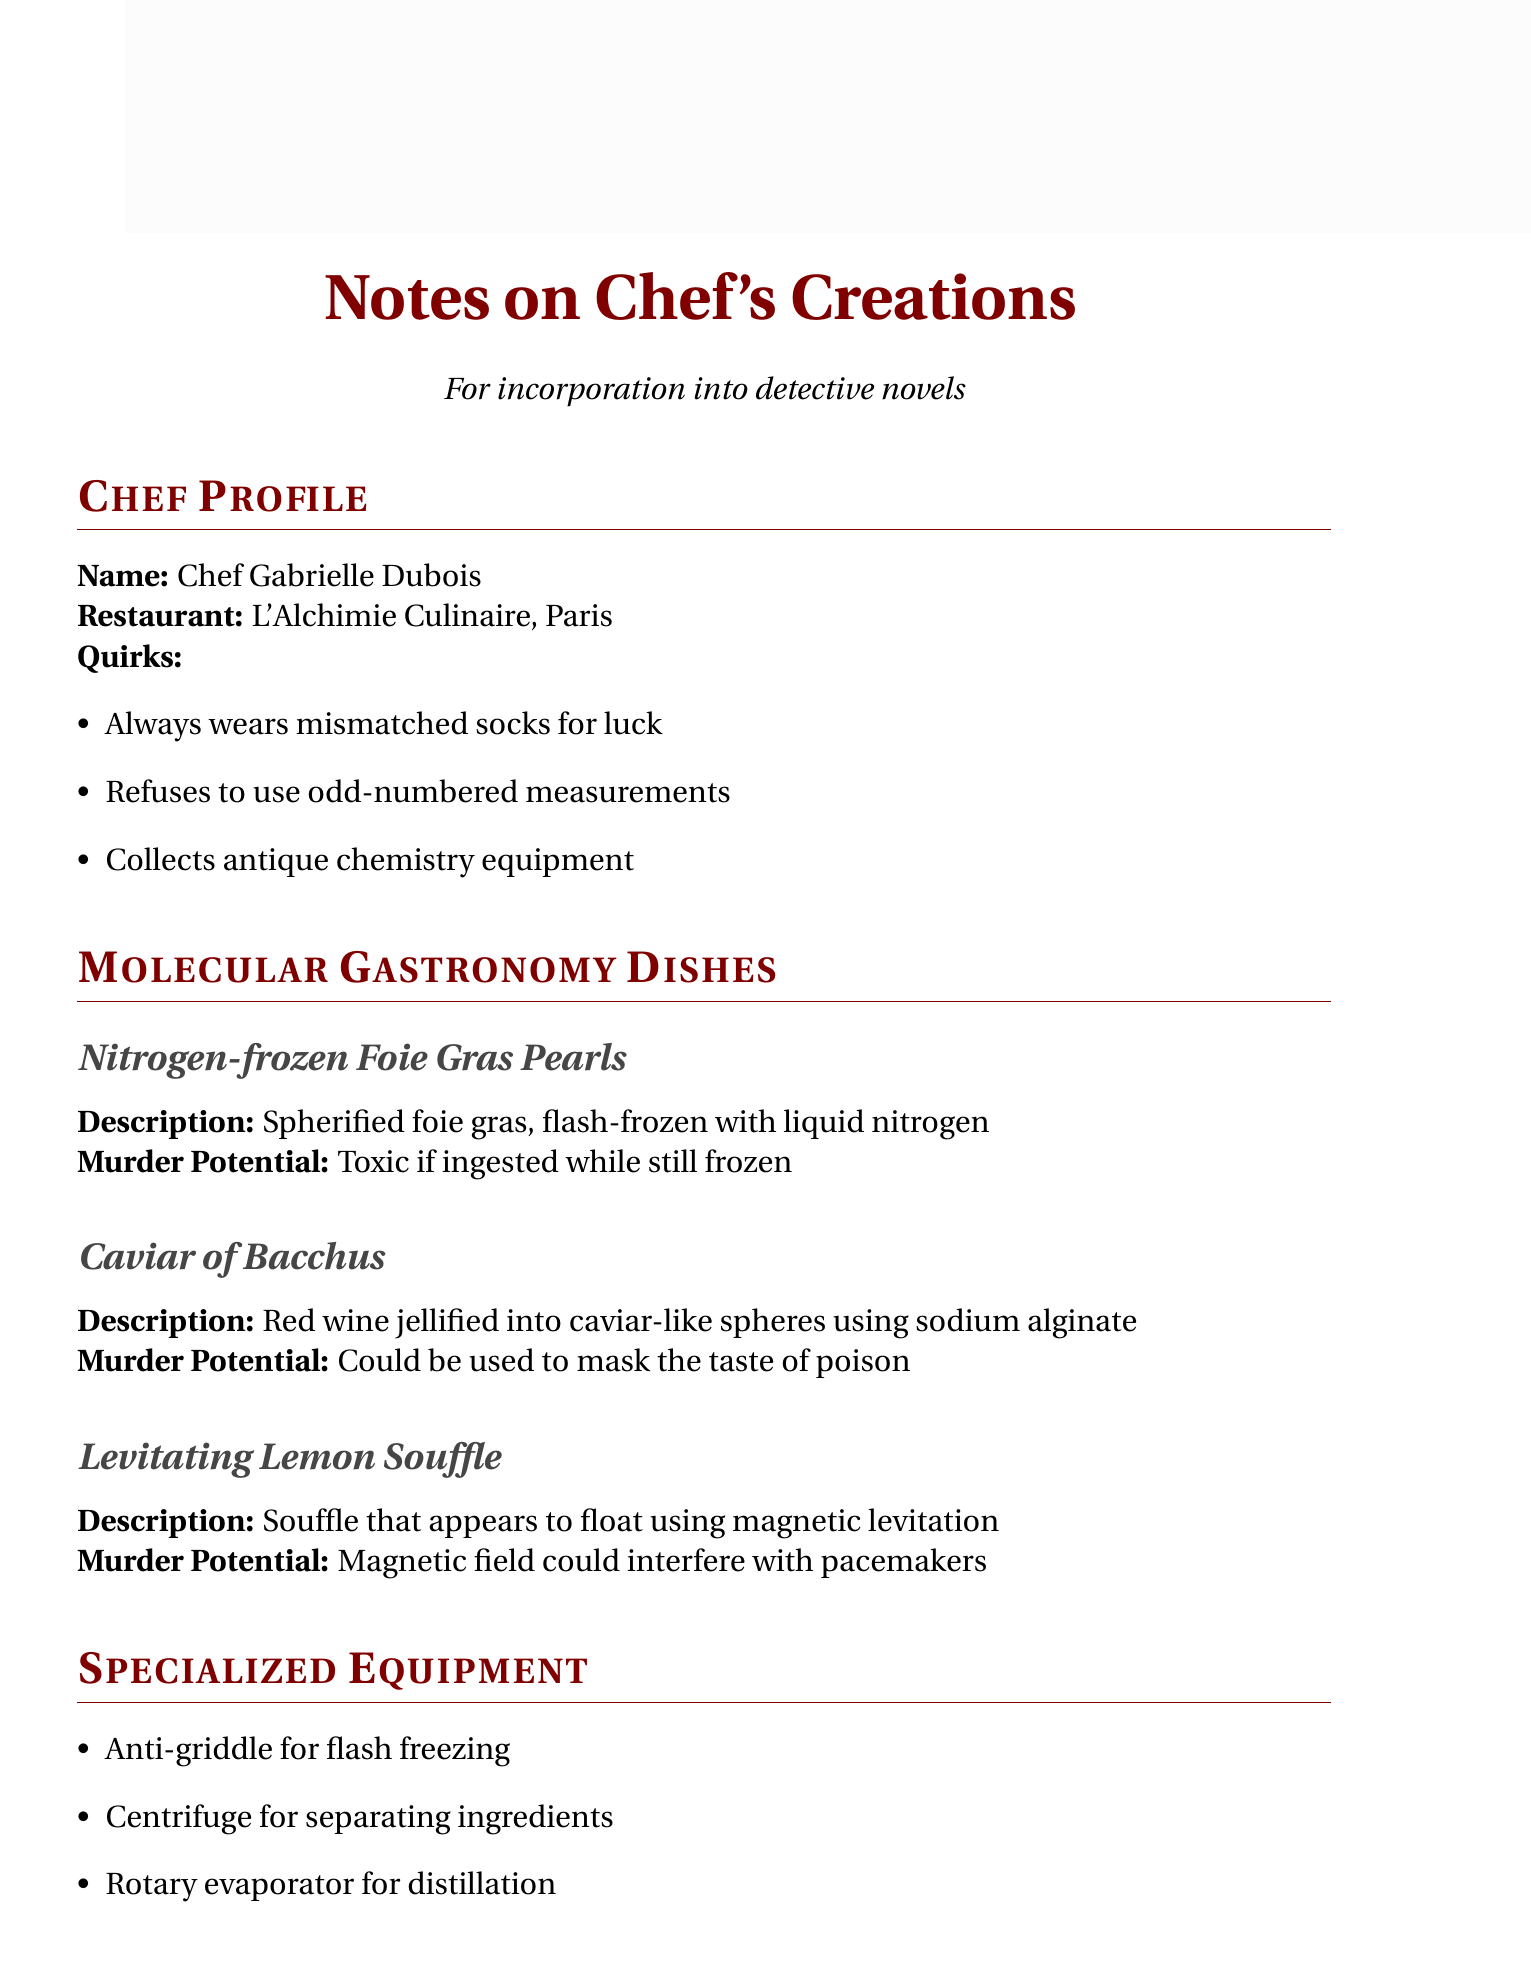What is the chef's name? The chef's name is listed at the top of the document under the Chef Profile section.
Answer: Chef Gabrielle Dubois What is the name of the restaurant? The restaurant name is mentioned in the Chef Profile section.
Answer: L'Alchimie Culinaire, Paris What is a key ingredient used in the molecular gastronomy dishes? Key ingredients are listed in a specific section; one of them is mentioned as a common item used in modern cooking.
Answer: Transglutaminase What is the murder potential of the Levitating Lemon Souffle? Each dish includes a section on its murder potential, specifically mentioning a safety concern.
Answer: Magnetic field could interfere with pacemakers What specialized equipment is used for flash freezing? The specialized equipment section highlights tools used in molecular gastronomy, including one specifically for freezing.
Answer: Anti-griddle How can the Caviar of Bacchus be potentially harmful? The murder potential of the Caviar of Bacchus explains how it could conceal toxic substances.
Answer: Could be used to mask the taste of poison What quirk does Chef Gabrielle Dubois have regarding measurements? The chef's quirks include personal preferences in the kitchen, such as specific types of measurements.
Answer: Refuses to use odd-numbered measurements What potential plot point involves an allergic reaction? The potential plot points section describes scenarios that could occur in a murder mystery involving food.
Answer: Victim dies from apparent allergic reaction, actually caused by hidden molecular gastronomy technique What type of gastronomy does Chef Gabrielle Dubois specialize in? The title mentions a specific style of cooking that focuses on physical and chemical transformations.
Answer: Molecular gastronomy 